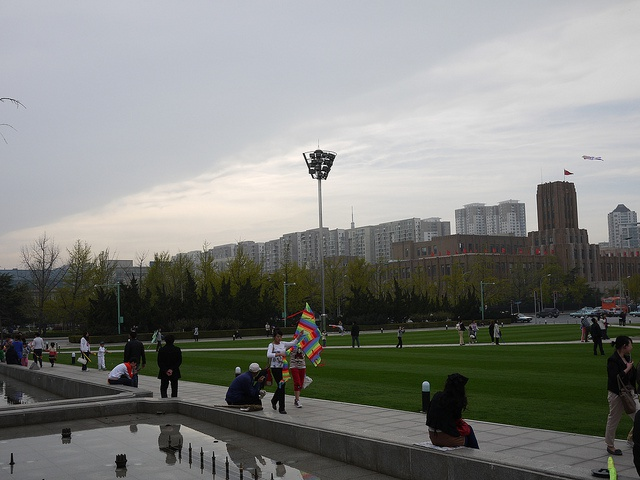Describe the objects in this image and their specific colors. I can see people in darkgray, black, gray, and maroon tones, people in darkgray, black, and gray tones, people in darkgray, black, maroon, and gray tones, people in darkgray, black, gray, and maroon tones, and people in darkgray, black, gray, and maroon tones in this image. 